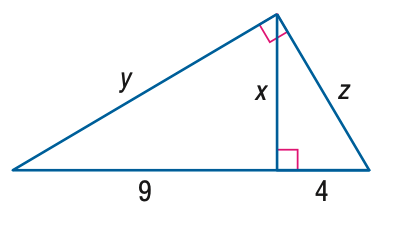Answer the mathemtical geometry problem and directly provide the correct option letter.
Question: Find x.
Choices: A: 1.5 B: 4 C: 6 D: 9 C 